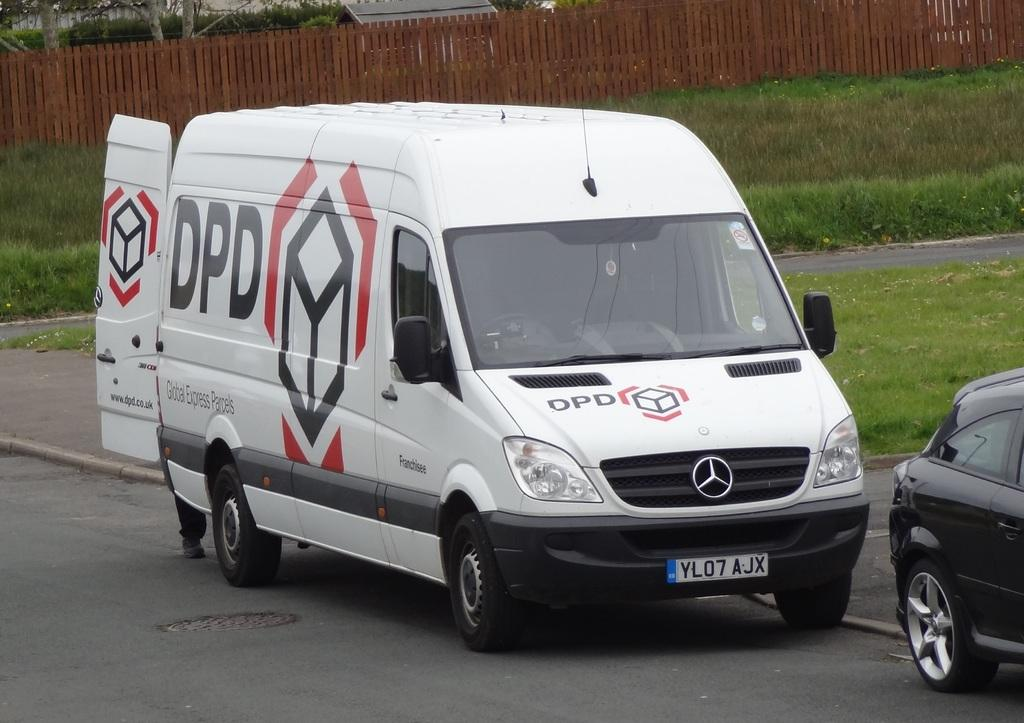Provide a one-sentence caption for the provided image. A Mercedes van that says DPD on the side and the front. 